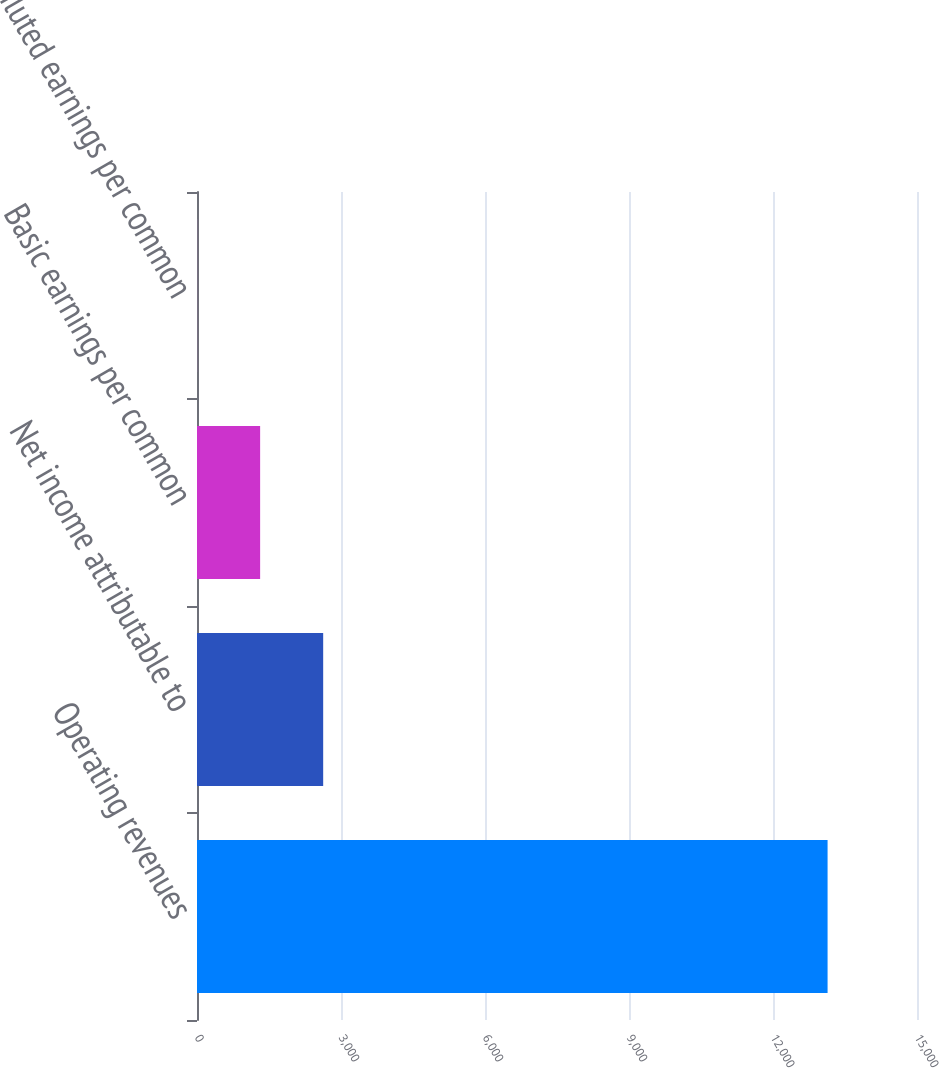<chart> <loc_0><loc_0><loc_500><loc_500><bar_chart><fcel>Operating revenues<fcel>Net income attributable to<fcel>Basic earnings per common<fcel>Diluted earnings per common<nl><fcel>13137<fcel>2628.73<fcel>1315.19<fcel>1.65<nl></chart> 